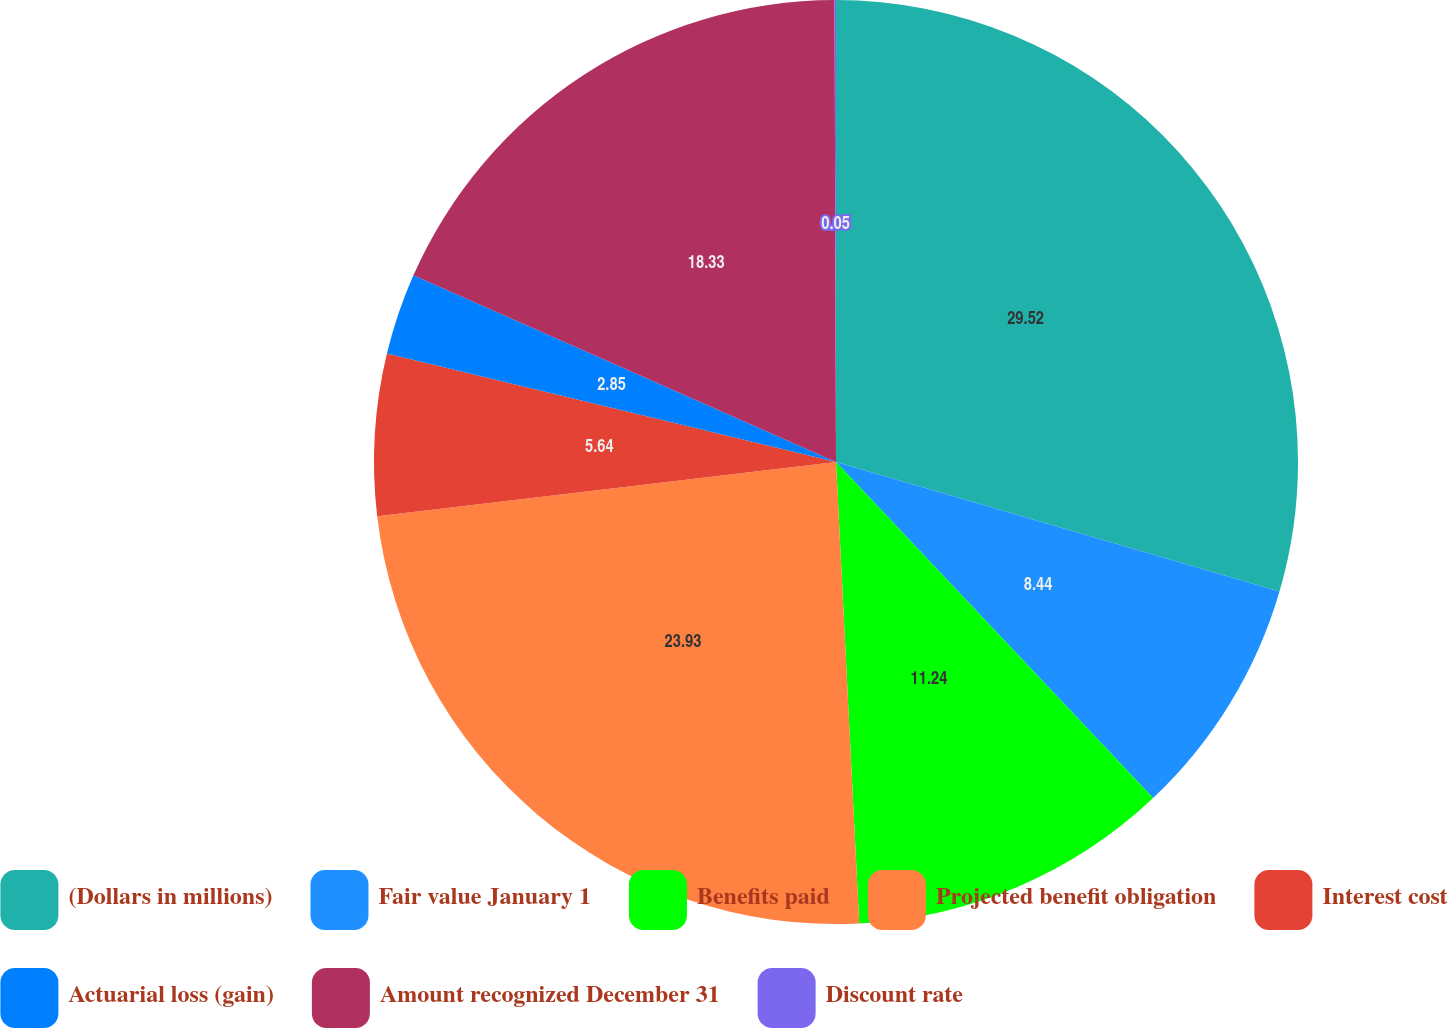Convert chart. <chart><loc_0><loc_0><loc_500><loc_500><pie_chart><fcel>(Dollars in millions)<fcel>Fair value January 1<fcel>Benefits paid<fcel>Projected benefit obligation<fcel>Interest cost<fcel>Actuarial loss (gain)<fcel>Amount recognized December 31<fcel>Discount rate<nl><fcel>29.52%<fcel>8.44%<fcel>11.24%<fcel>23.93%<fcel>5.64%<fcel>2.85%<fcel>18.33%<fcel>0.05%<nl></chart> 